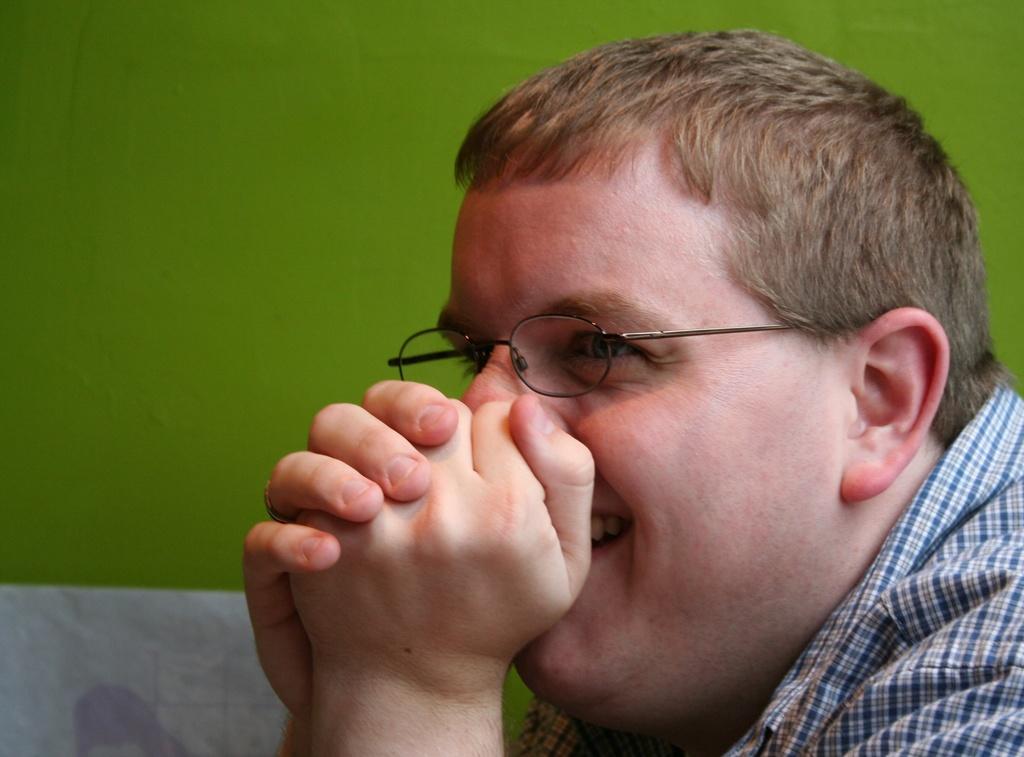How would you summarize this image in a sentence or two? There is a man in the foreground area of the image, it seems like a wall in the background. 